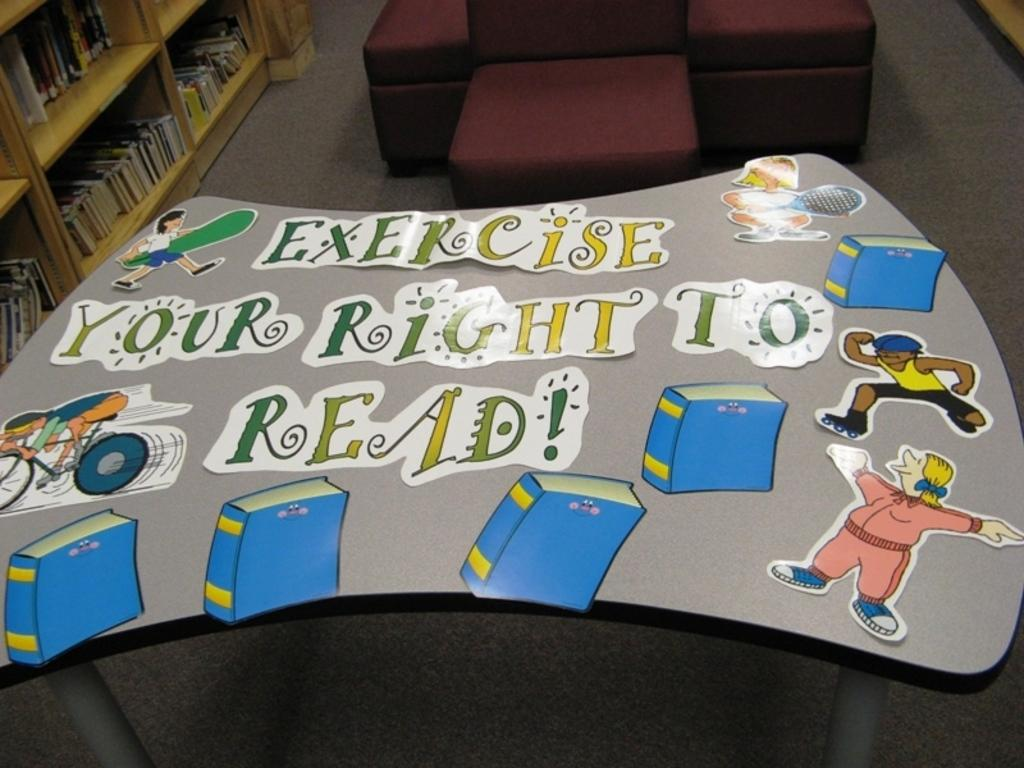<image>
Render a clear and concise summary of the photo. the mat on the floor says Exercise your right to read 